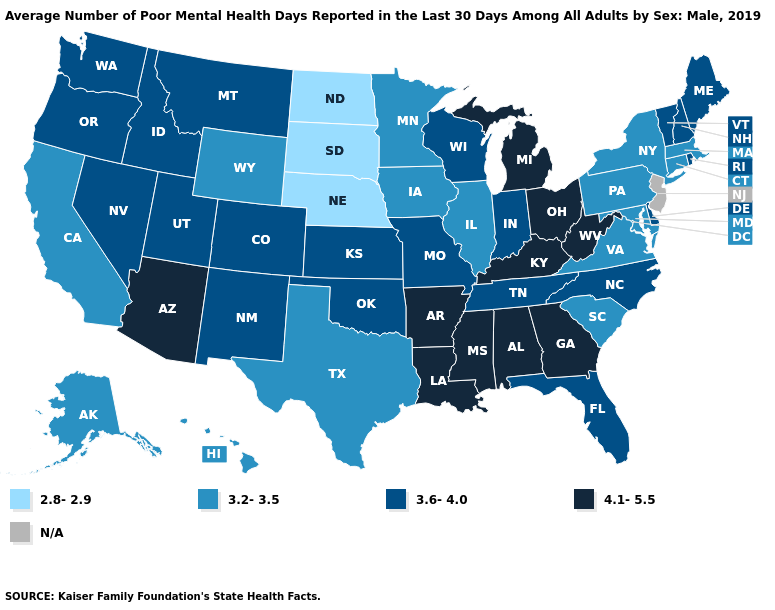What is the lowest value in states that border New Jersey?
Write a very short answer. 3.2-3.5. Name the states that have a value in the range 4.1-5.5?
Answer briefly. Alabama, Arizona, Arkansas, Georgia, Kentucky, Louisiana, Michigan, Mississippi, Ohio, West Virginia. Name the states that have a value in the range 4.1-5.5?
Give a very brief answer. Alabama, Arizona, Arkansas, Georgia, Kentucky, Louisiana, Michigan, Mississippi, Ohio, West Virginia. What is the value of Oregon?
Quick response, please. 3.6-4.0. Name the states that have a value in the range N/A?
Write a very short answer. New Jersey. Name the states that have a value in the range 3.6-4.0?
Concise answer only. Colorado, Delaware, Florida, Idaho, Indiana, Kansas, Maine, Missouri, Montana, Nevada, New Hampshire, New Mexico, North Carolina, Oklahoma, Oregon, Rhode Island, Tennessee, Utah, Vermont, Washington, Wisconsin. What is the value of Kansas?
Quick response, please. 3.6-4.0. Name the states that have a value in the range 3.6-4.0?
Keep it brief. Colorado, Delaware, Florida, Idaho, Indiana, Kansas, Maine, Missouri, Montana, Nevada, New Hampshire, New Mexico, North Carolina, Oklahoma, Oregon, Rhode Island, Tennessee, Utah, Vermont, Washington, Wisconsin. Among the states that border Kansas , does Missouri have the lowest value?
Short answer required. No. Name the states that have a value in the range N/A?
Quick response, please. New Jersey. What is the value of South Carolina?
Be succinct. 3.2-3.5. Which states hav the highest value in the West?
Write a very short answer. Arizona. Does the first symbol in the legend represent the smallest category?
Be succinct. Yes. What is the value of Maine?
Be succinct. 3.6-4.0. What is the value of Maryland?
Concise answer only. 3.2-3.5. 